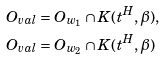<formula> <loc_0><loc_0><loc_500><loc_500>O _ { v a l } & = O _ { w _ { 1 } } \cap K ( t ^ { H } , \beta ) , \\ O _ { v a l } & = O _ { w _ { 2 } } \cap K ( t ^ { H } , \beta )</formula> 